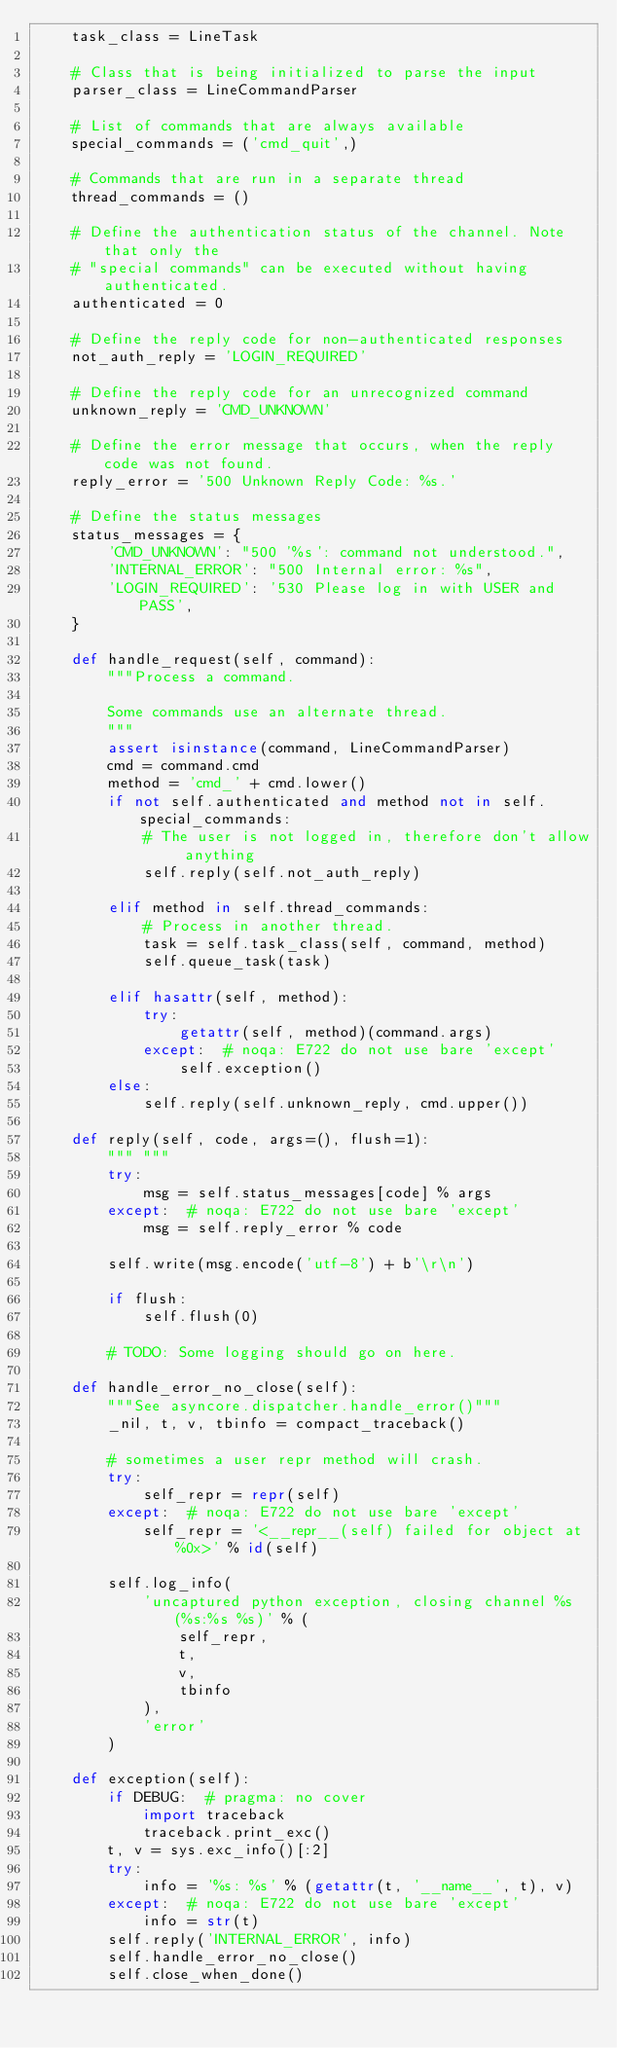<code> <loc_0><loc_0><loc_500><loc_500><_Python_>    task_class = LineTask

    # Class that is being initialized to parse the input
    parser_class = LineCommandParser

    # List of commands that are always available
    special_commands = ('cmd_quit',)

    # Commands that are run in a separate thread
    thread_commands = ()

    # Define the authentication status of the channel. Note that only the
    # "special commands" can be executed without having authenticated.
    authenticated = 0

    # Define the reply code for non-authenticated responses
    not_auth_reply = 'LOGIN_REQUIRED'

    # Define the reply code for an unrecognized command
    unknown_reply = 'CMD_UNKNOWN'

    # Define the error message that occurs, when the reply code was not found.
    reply_error = '500 Unknown Reply Code: %s.'

    # Define the status messages
    status_messages = {
        'CMD_UNKNOWN': "500 '%s': command not understood.",
        'INTERNAL_ERROR': "500 Internal error: %s",
        'LOGIN_REQUIRED': '530 Please log in with USER and PASS',
    }

    def handle_request(self, command):
        """Process a command.

        Some commands use an alternate thread.
        """
        assert isinstance(command, LineCommandParser)
        cmd = command.cmd
        method = 'cmd_' + cmd.lower()
        if not self.authenticated and method not in self.special_commands:
            # The user is not logged in, therefore don't allow anything
            self.reply(self.not_auth_reply)

        elif method in self.thread_commands:
            # Process in another thread.
            task = self.task_class(self, command, method)
            self.queue_task(task)

        elif hasattr(self, method):
            try:
                getattr(self, method)(command.args)
            except:  # noqa: E722 do not use bare 'except'
                self.exception()
        else:
            self.reply(self.unknown_reply, cmd.upper())

    def reply(self, code, args=(), flush=1):
        """ """
        try:
            msg = self.status_messages[code] % args
        except:  # noqa: E722 do not use bare 'except'
            msg = self.reply_error % code

        self.write(msg.encode('utf-8') + b'\r\n')

        if flush:
            self.flush(0)

        # TODO: Some logging should go on here.

    def handle_error_no_close(self):
        """See asyncore.dispatcher.handle_error()"""
        _nil, t, v, tbinfo = compact_traceback()

        # sometimes a user repr method will crash.
        try:
            self_repr = repr(self)
        except:  # noqa: E722 do not use bare 'except'
            self_repr = '<__repr__(self) failed for object at %0x>' % id(self)

        self.log_info(
            'uncaptured python exception, closing channel %s (%s:%s %s)' % (
                self_repr,
                t,
                v,
                tbinfo
            ),
            'error'
        )

    def exception(self):
        if DEBUG:  # pragma: no cover
            import traceback
            traceback.print_exc()
        t, v = sys.exc_info()[:2]
        try:
            info = '%s: %s' % (getattr(t, '__name__', t), v)
        except:  # noqa: E722 do not use bare 'except'
            info = str(t)
        self.reply('INTERNAL_ERROR', info)
        self.handle_error_no_close()
        self.close_when_done()
</code> 